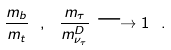<formula> <loc_0><loc_0><loc_500><loc_500>\frac { m _ { b } } { m _ { t } } \ , \ \frac { m _ { \tau } } { m ^ { D } _ { \nu _ { \tau } } } \longrightarrow 1 \ .</formula> 